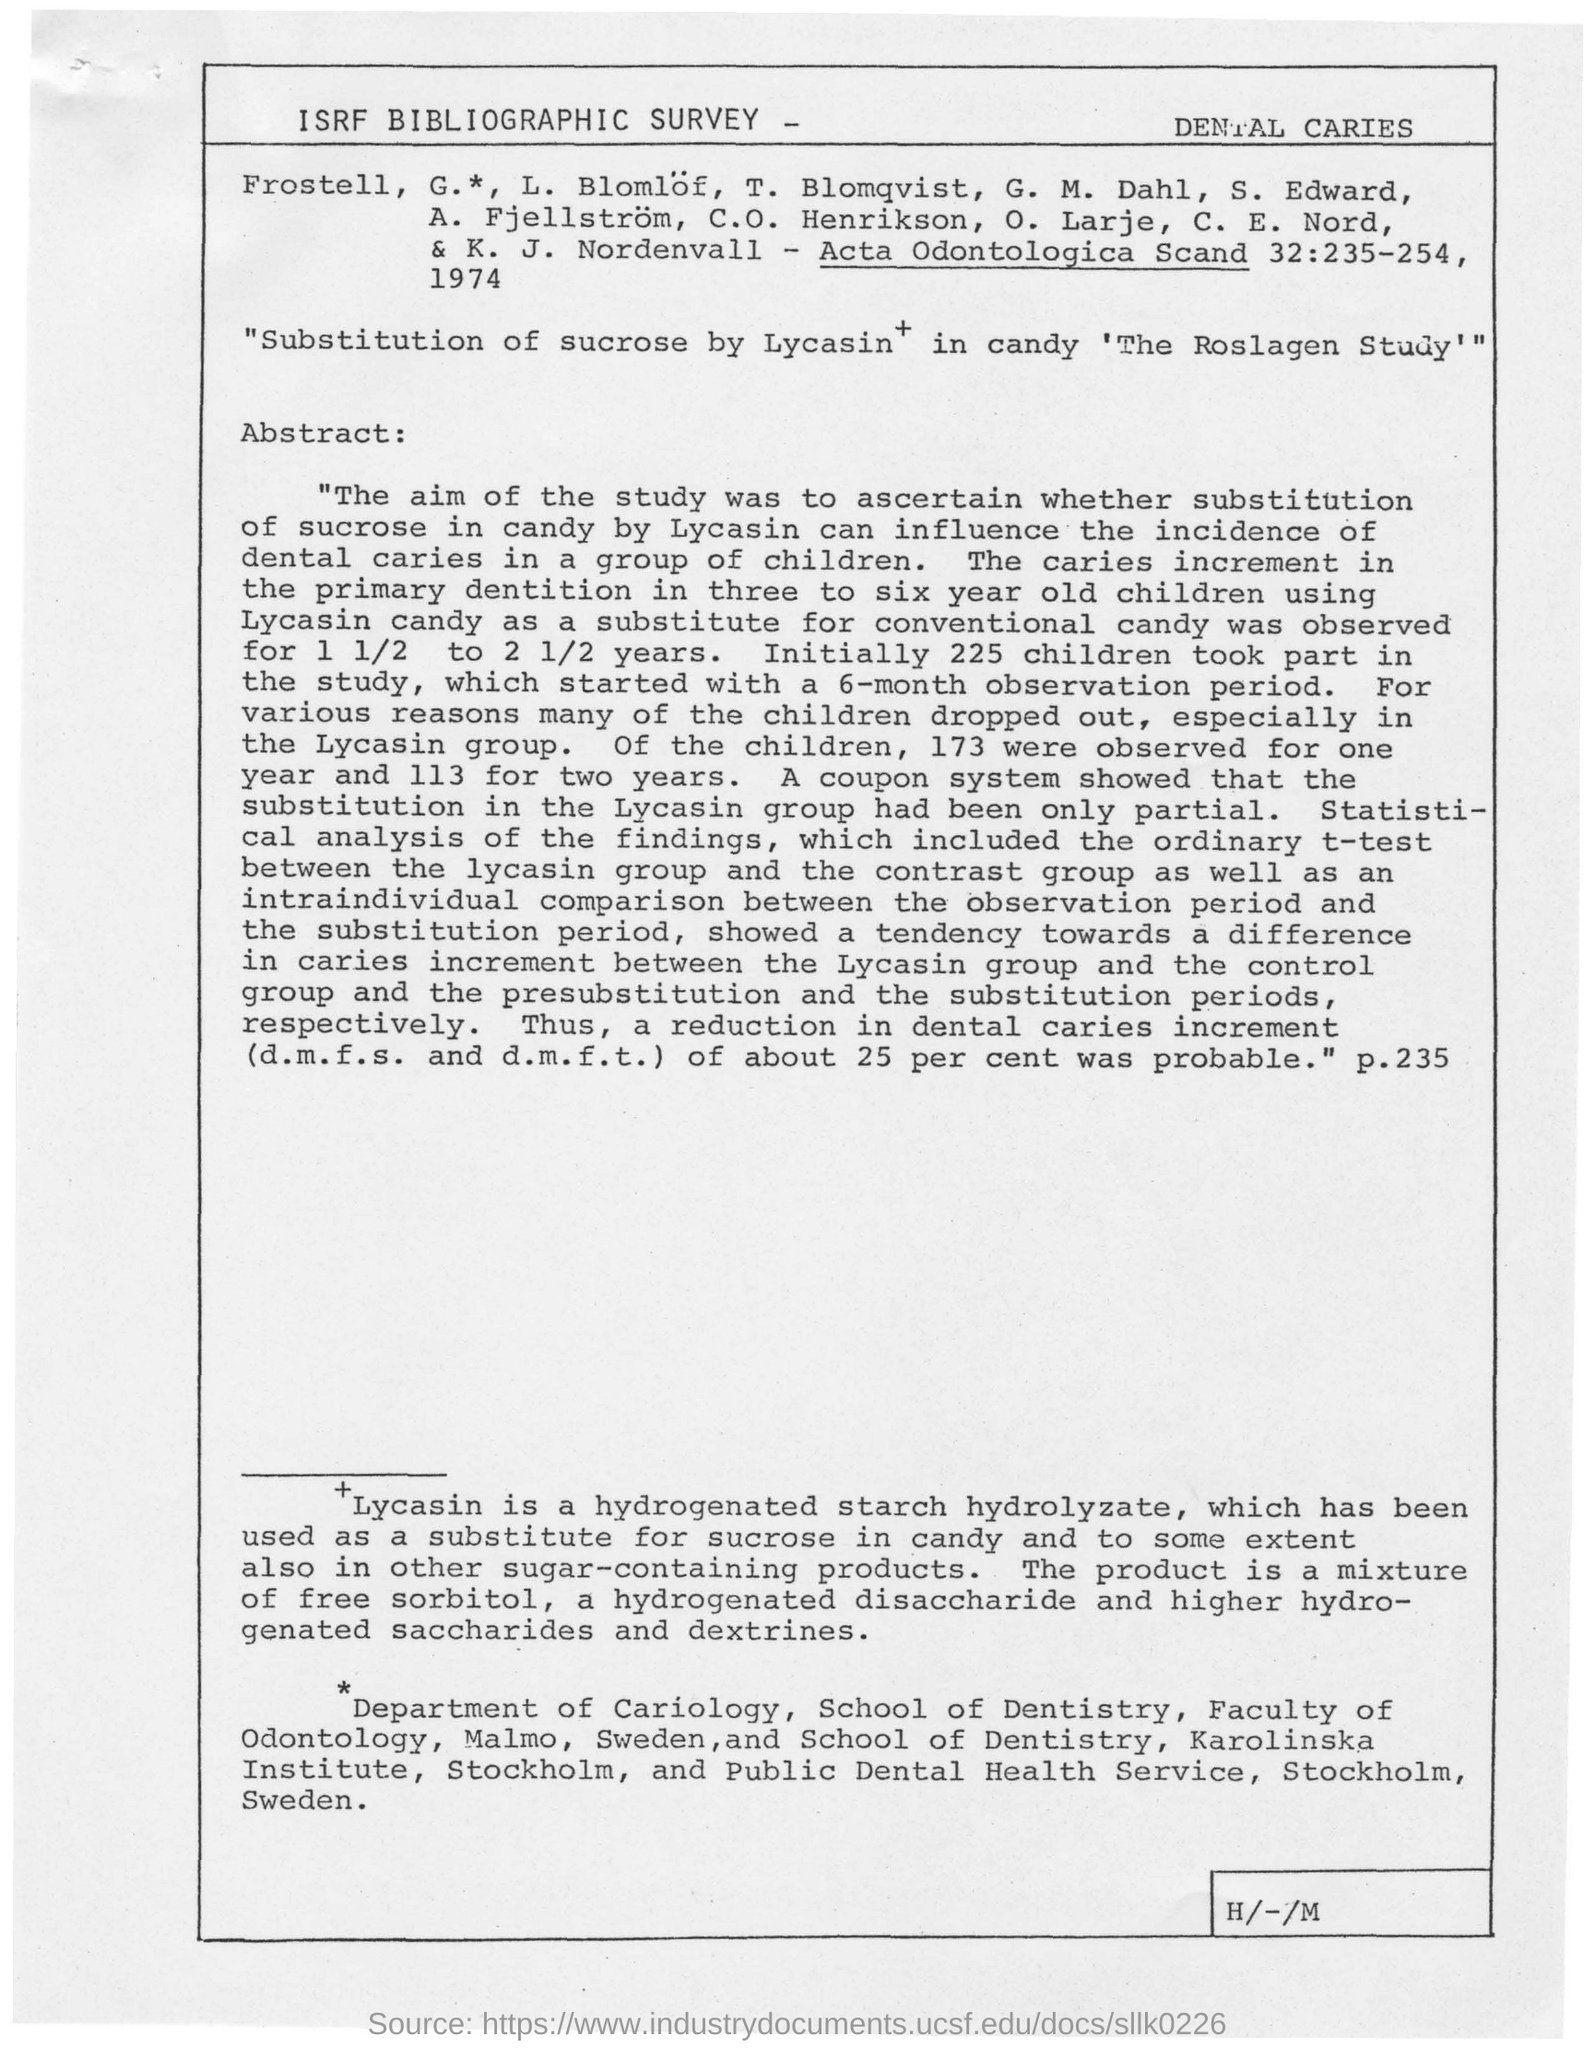List a handful of essential elements in this visual. Lycasin, a hydrogenated starch hydrolyzate, has been used as a substitute for sucrose in the production of candy. The age group of children affected by dental caries is three to six years old. The coupon system showed that the substitution in the Lycasin group had been partial. The study on a substitute for conventional candy was conducted for a period of 1 1/2 to 2 1/2 years. It was observed that 173 children were present for one year. 